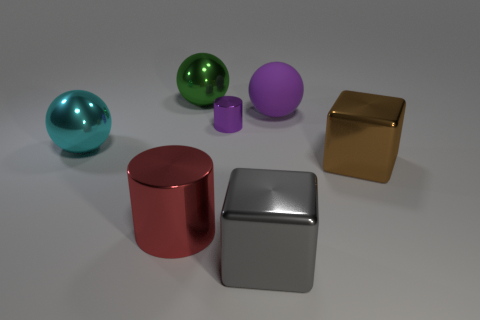Subtract 1 balls. How many balls are left? 2 Add 1 big rubber spheres. How many objects exist? 8 Subtract all spheres. How many objects are left? 4 Subtract all small yellow shiny cubes. Subtract all big green metal spheres. How many objects are left? 6 Add 7 tiny purple cylinders. How many tiny purple cylinders are left? 8 Add 1 big purple spheres. How many big purple spheres exist? 2 Subtract 1 cyan balls. How many objects are left? 6 